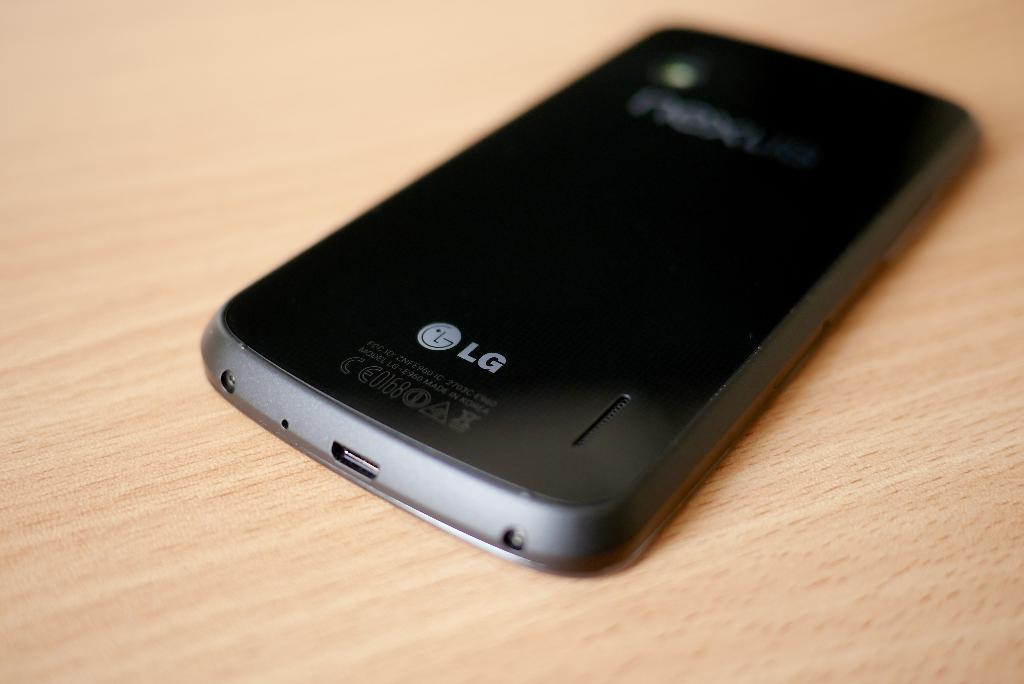Provide a one-sentence caption for the provided image. A black phone rests on the table and the make is LG. 